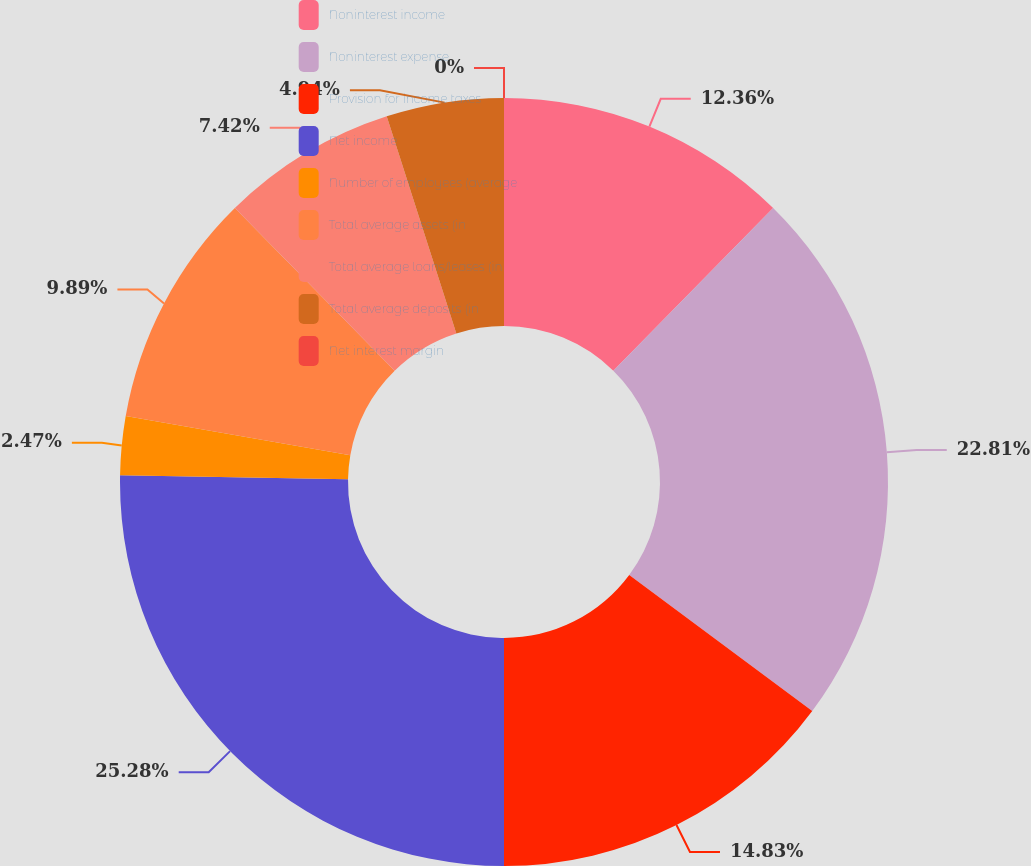Convert chart. <chart><loc_0><loc_0><loc_500><loc_500><pie_chart><fcel>Noninterest income<fcel>Noninterest expense<fcel>Provision for income taxes<fcel>Net income<fcel>Number of employees (average<fcel>Total average assets (in<fcel>Total average loans/leases (in<fcel>Total average deposits (in<fcel>Net interest margin<nl><fcel>12.36%<fcel>22.81%<fcel>14.83%<fcel>25.28%<fcel>2.47%<fcel>9.89%<fcel>7.42%<fcel>4.94%<fcel>0.0%<nl></chart> 